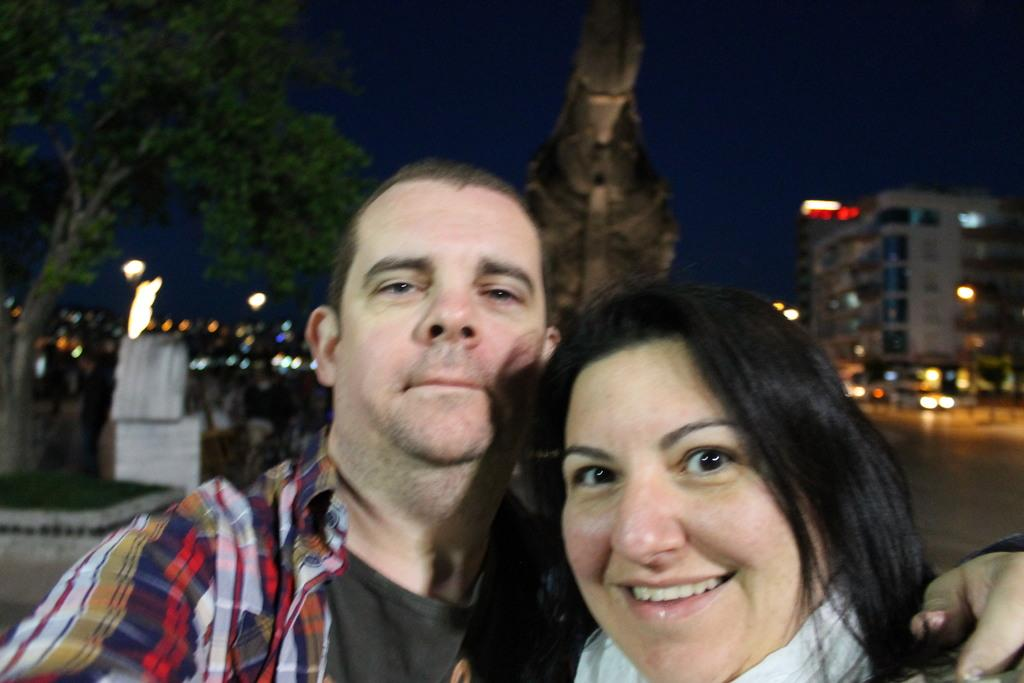How many people are in the image? There are two people in the image. Can you describe one of the people in the image? There is a woman in the image, and she is smiling. What can be seen in the background of the image? There is a building, a statue, a tree, lights, some objects, and the sky visible in the background of the image. What is the name of the field in the image? There is no field present in the image. What type of bubble can be seen in the image? There are no bubbles present in the image. 